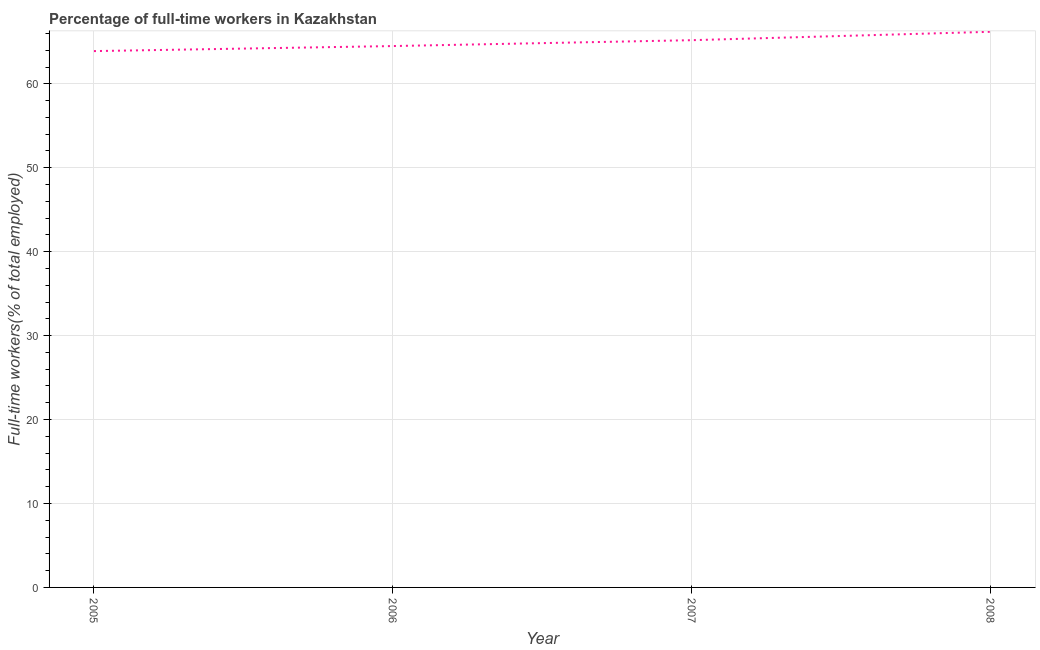What is the percentage of full-time workers in 2008?
Provide a succinct answer. 66.2. Across all years, what is the maximum percentage of full-time workers?
Give a very brief answer. 66.2. Across all years, what is the minimum percentage of full-time workers?
Your response must be concise. 63.9. In which year was the percentage of full-time workers maximum?
Make the answer very short. 2008. What is the sum of the percentage of full-time workers?
Keep it short and to the point. 259.8. What is the difference between the percentage of full-time workers in 2006 and 2007?
Your answer should be very brief. -0.7. What is the average percentage of full-time workers per year?
Make the answer very short. 64.95. What is the median percentage of full-time workers?
Your answer should be compact. 64.85. In how many years, is the percentage of full-time workers greater than 12 %?
Provide a short and direct response. 4. Do a majority of the years between 2005 and 2008 (inclusive) have percentage of full-time workers greater than 8 %?
Make the answer very short. Yes. What is the ratio of the percentage of full-time workers in 2005 to that in 2008?
Offer a terse response. 0.97. Is the percentage of full-time workers in 2006 less than that in 2008?
Make the answer very short. Yes. What is the difference between the highest and the second highest percentage of full-time workers?
Provide a succinct answer. 1. What is the difference between the highest and the lowest percentage of full-time workers?
Make the answer very short. 2.3. In how many years, is the percentage of full-time workers greater than the average percentage of full-time workers taken over all years?
Keep it short and to the point. 2. Does the percentage of full-time workers monotonically increase over the years?
Provide a succinct answer. Yes. Are the values on the major ticks of Y-axis written in scientific E-notation?
Keep it short and to the point. No. What is the title of the graph?
Your answer should be very brief. Percentage of full-time workers in Kazakhstan. What is the label or title of the Y-axis?
Provide a succinct answer. Full-time workers(% of total employed). What is the Full-time workers(% of total employed) of 2005?
Provide a succinct answer. 63.9. What is the Full-time workers(% of total employed) of 2006?
Give a very brief answer. 64.5. What is the Full-time workers(% of total employed) in 2007?
Provide a short and direct response. 65.2. What is the Full-time workers(% of total employed) of 2008?
Make the answer very short. 66.2. What is the difference between the Full-time workers(% of total employed) in 2005 and 2006?
Provide a succinct answer. -0.6. What is the difference between the Full-time workers(% of total employed) in 2005 and 2008?
Offer a terse response. -2.3. What is the difference between the Full-time workers(% of total employed) in 2007 and 2008?
Offer a very short reply. -1. What is the ratio of the Full-time workers(% of total employed) in 2005 to that in 2008?
Offer a very short reply. 0.96. What is the ratio of the Full-time workers(% of total employed) in 2006 to that in 2007?
Offer a very short reply. 0.99. What is the ratio of the Full-time workers(% of total employed) in 2006 to that in 2008?
Ensure brevity in your answer.  0.97. 